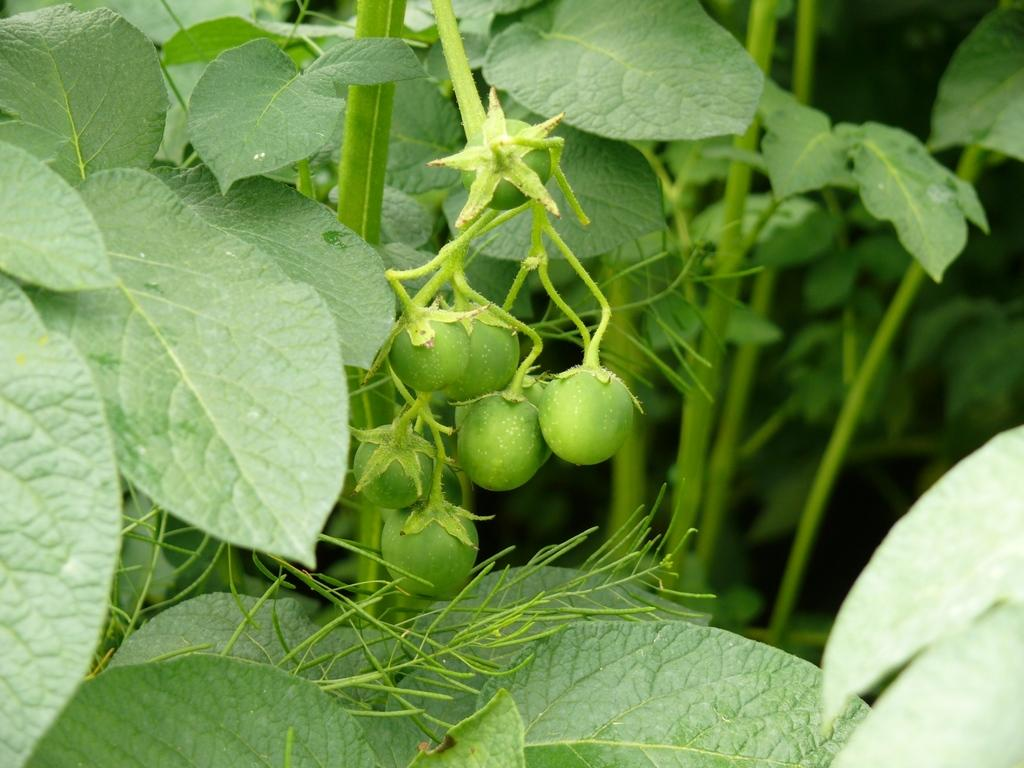What type of plants can be seen in the image? There are green plants in the image. What is the condition of the fruits in the image? There appear to be unripe fruits in the image. Can you tell me how much honey is being produced by the plants in the image? There is no honey production mentioned or visible in the image, as it features green plants and unripe fruits. 